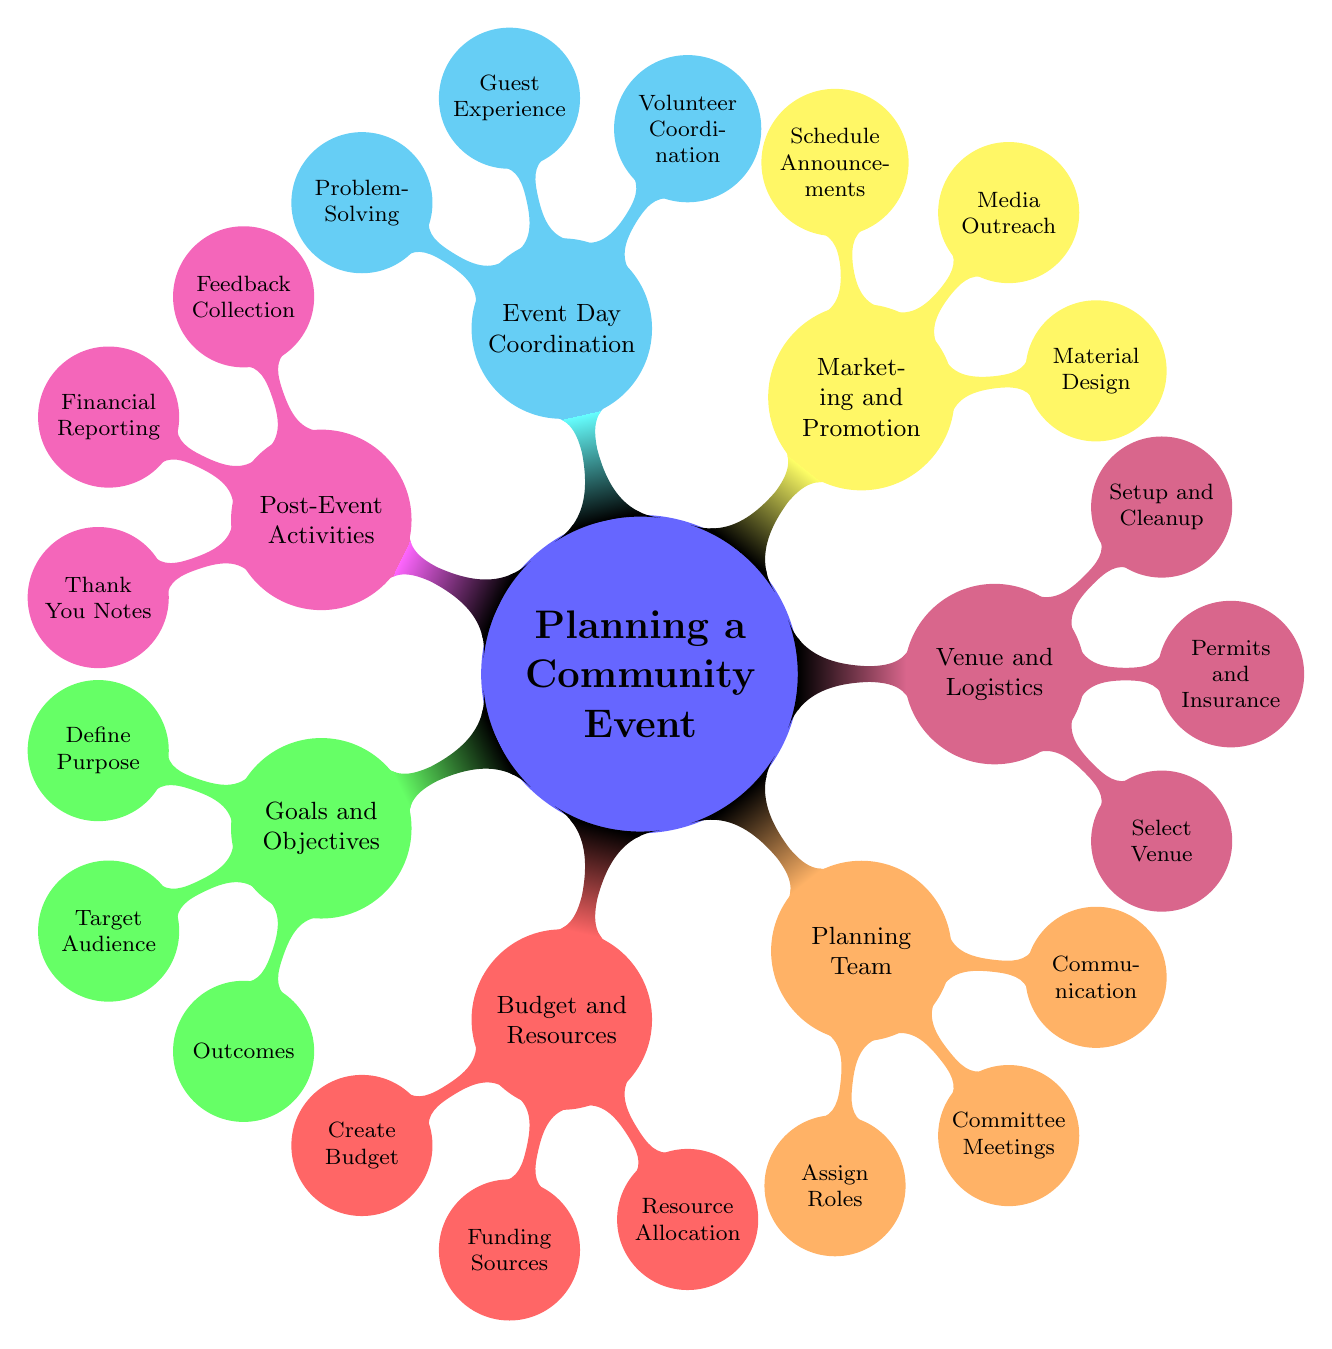What is the main purpose of the "Planning a Community Event"? The main purpose of the event can be categorized under "Goals and Objectives," which includes defining the purpose such as fundraising or celebration.
Answer: Goals and Objectives How many children are there under "Budget and Resources"? Under "Budget and Resources," there are three subcategories: Create Budget, Funding Sources, and Resource Allocation.
Answer: 3 What is one responsibility of the "Planning Team"? The "Planning Team" includes responsibilities like Assign Roles, which entails designating tasks such as event coordinator or treasurer.
Answer: Assign Roles Name one activity included in the "Post-Event Activities". One of the activities in "Post-Event Activities" is collecting feedback from attendees to assess the event.
Answer: Feedback Collection Which section includes the task of selecting a venue? The task of selecting a venue is part of the "Venue and Logistics" section.
Answer: Venue and Logistics Identify a specific role mentioned in the "Event Day Coordination". Under "Event Day Coordination," one specific role outlined is Volunteer Coordination, which focuses on briefing volunteers.
Answer: Volunteer Coordination How is the section "Marketing and Promotion" represented visually in the diagram? The section "Marketing and Promotion" is represented by a node with a distinct color (yellow) and child nodes indicating various tasks related to promotion such as Material Design.
Answer: Yellow What type of communication is emphasized in the "Planning Team"? The "Planning Team" emphasizes clear communication channels, which might include email updates or group chats to ensure progress.
Answer: Communication What is a potential result under "Goals and Objectives"? A measurable outcome under "Goals and Objectives" could include funds raised during the event or the number of attendees.
Answer: Outcomes What should be surveyed in the "Post-Event Activities"? In "Post-Event Activities," it is essential to survey attendees, volunteers, and stakeholders for their feedback on the event.
Answer: Feedback 